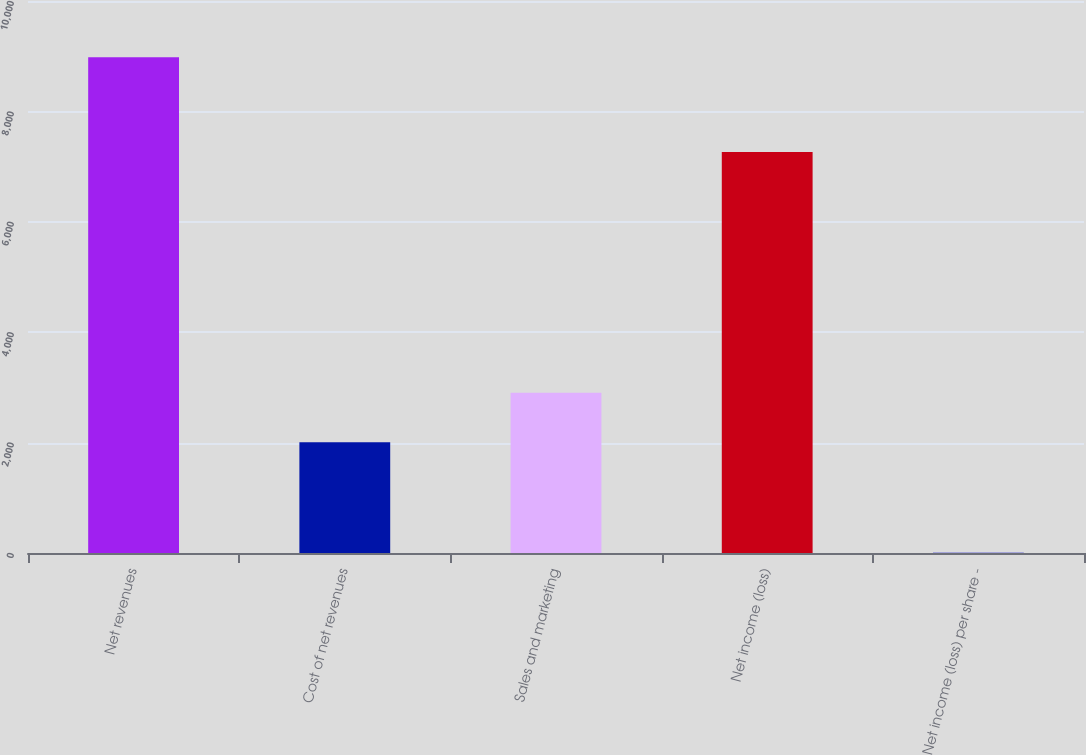Convert chart to OTSL. <chart><loc_0><loc_0><loc_500><loc_500><bar_chart><fcel>Net revenues<fcel>Cost of net revenues<fcel>Sales and marketing<fcel>Net income (loss)<fcel>Net income (loss) per share -<nl><fcel>8979<fcel>2007<fcel>2904.26<fcel>7266<fcel>6.35<nl></chart> 